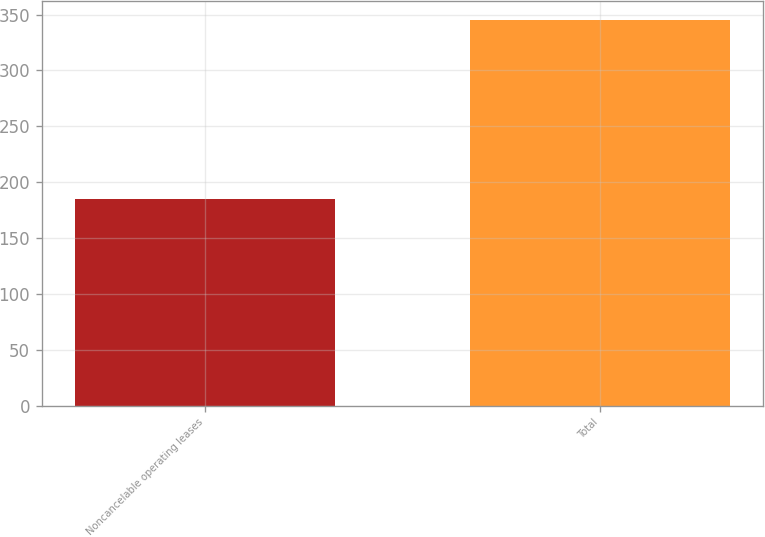Convert chart. <chart><loc_0><loc_0><loc_500><loc_500><bar_chart><fcel>Noncancelable operating leases<fcel>Total<nl><fcel>185<fcel>345<nl></chart> 